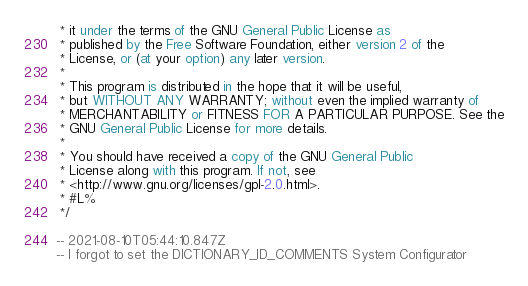Convert code to text. <code><loc_0><loc_0><loc_500><loc_500><_SQL_> * it under the terms of the GNU General Public License as
 * published by the Free Software Foundation, either version 2 of the
 * License, or (at your option) any later version.
 *
 * This program is distributed in the hope that it will be useful,
 * but WITHOUT ANY WARRANTY; without even the implied warranty of
 * MERCHANTABILITY or FITNESS FOR A PARTICULAR PURPOSE. See the
 * GNU General Public License for more details.
 *
 * You should have received a copy of the GNU General Public
 * License along with this program. If not, see
 * <http://www.gnu.org/licenses/gpl-2.0.html>.
 * #L%
 */

-- 2021-08-10T05:44:10.847Z
-- I forgot to set the DICTIONARY_ID_COMMENTS System Configurator</code> 